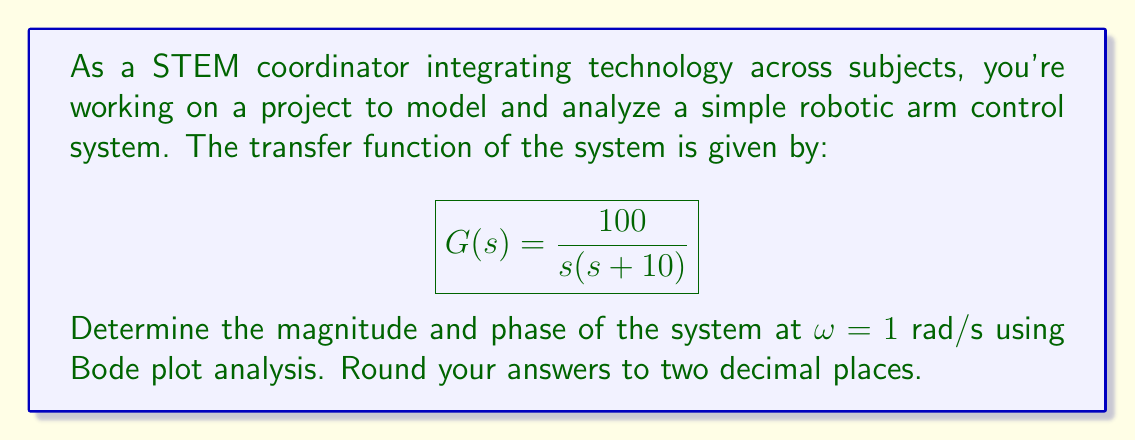Could you help me with this problem? To analyze the frequency response using Bode plots, we'll follow these steps:

1) First, let's break down the transfer function:
   $$G(s) = \frac{100}{s(s + 10)} = \frac{100}{s} \cdot \frac{1}{s + 10}$$

2) Now, we'll calculate the magnitude and phase for each term separately at ω = 1 rad/s:

   For $\frac{100}{s}$:
   - Magnitude: $|G_1(jω)| = \frac{100}{ω} = \frac{100}{1} = 100$
   - Phase: $\angle G_1(jω) = -90°$ (integrator)

   For $\frac{1}{s + 10}$:
   - Magnitude: $|G_2(jω)| = \frac{1}{\sqrt{ω^2 + 10^2}} = \frac{1}{\sqrt{1^2 + 10^2}} = \frac{1}{\sqrt{101}} \approx 0.0995$
   - Phase: $\angle G_2(jω) = -\tan^{-1}(\frac{ω}{10}) = -\tan^{-1}(\frac{1}{10}) \approx -5.71°$

3) To get the total magnitude, multiply the magnitudes:
   $|G(jω)| = 100 \cdot 0.0995 = 9.95$

4) To get the total phase, add the phases:
   $\angle G(jω) = -90° + (-5.71°) = -95.71°$

5) Rounding to two decimal places:
   Magnitude: 9.95
   Phase: -95.71°
Answer: At ω = 1 rad/s:
Magnitude: 9.95
Phase: -95.71° 